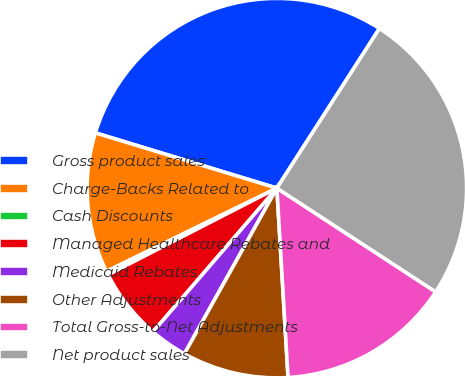<chart> <loc_0><loc_0><loc_500><loc_500><pie_chart><fcel>Gross product sales<fcel>Charge-Backs Related to<fcel>Cash Discounts<fcel>Managed Healthcare Rebates and<fcel>Medicaid Rebates<fcel>Other Adjustments<fcel>Total Gross-to-Net Adjustments<fcel>Net product sales<nl><fcel>29.38%<fcel>11.94%<fcel>0.31%<fcel>6.13%<fcel>3.22%<fcel>9.04%<fcel>14.85%<fcel>25.12%<nl></chart> 